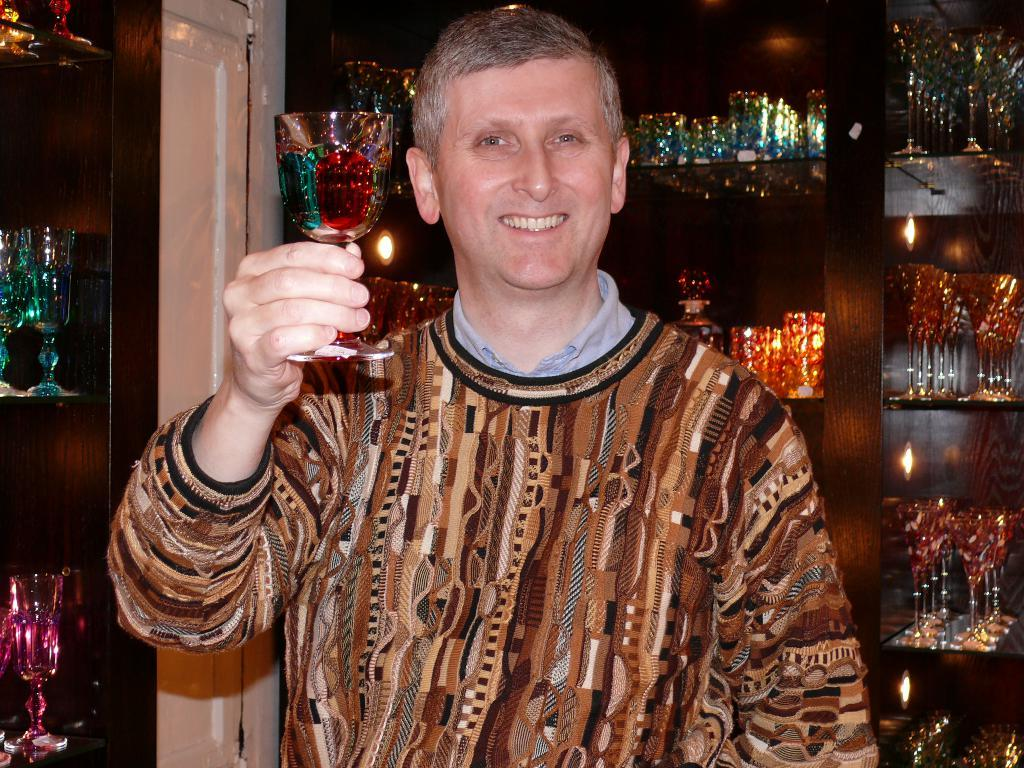Who is present in the image? There is a person in the image. What is the person holding in his hand? The person is holding a glass in his hand. What can be seen in the background of the image? There are shelves in the background of the image. How are the shelves arranged? The shelves are arranged with glasses. What type of pies is the person considering as a hobby in the image? There is no mention of pies or hobbies in the image; it only shows a person holding a glass and shelves arranged with glasses. 